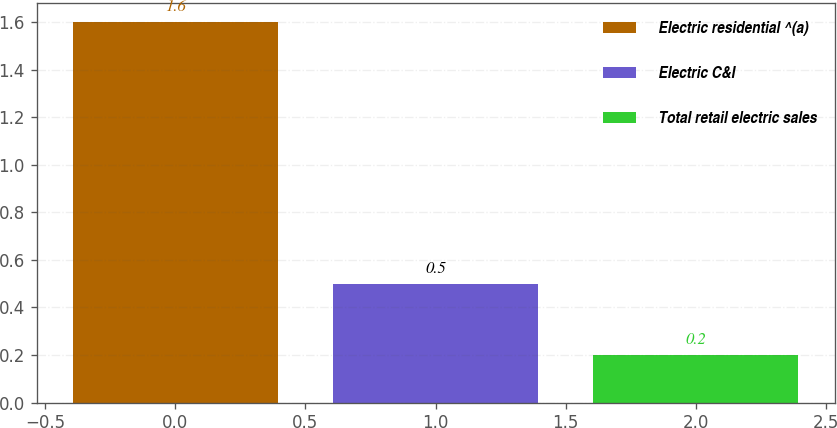<chart> <loc_0><loc_0><loc_500><loc_500><bar_chart><fcel>Electric residential ^(a)<fcel>Electric C&I<fcel>Total retail electric sales<nl><fcel>1.6<fcel>0.5<fcel>0.2<nl></chart> 